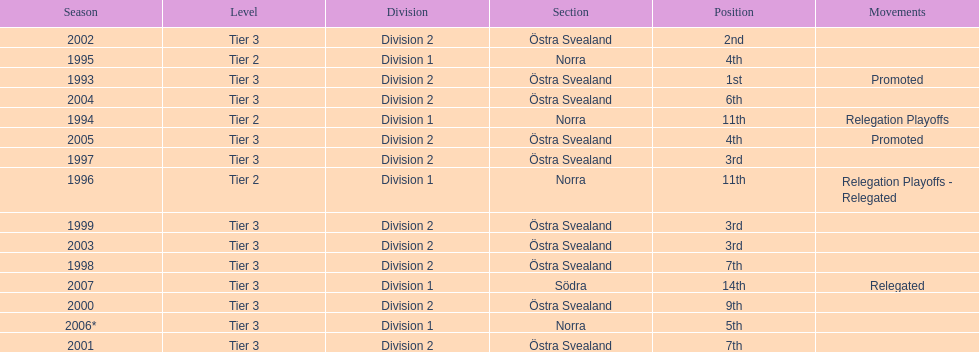In 2000 they finished 9th in their division, did they perform better or worse the next season? Better. 